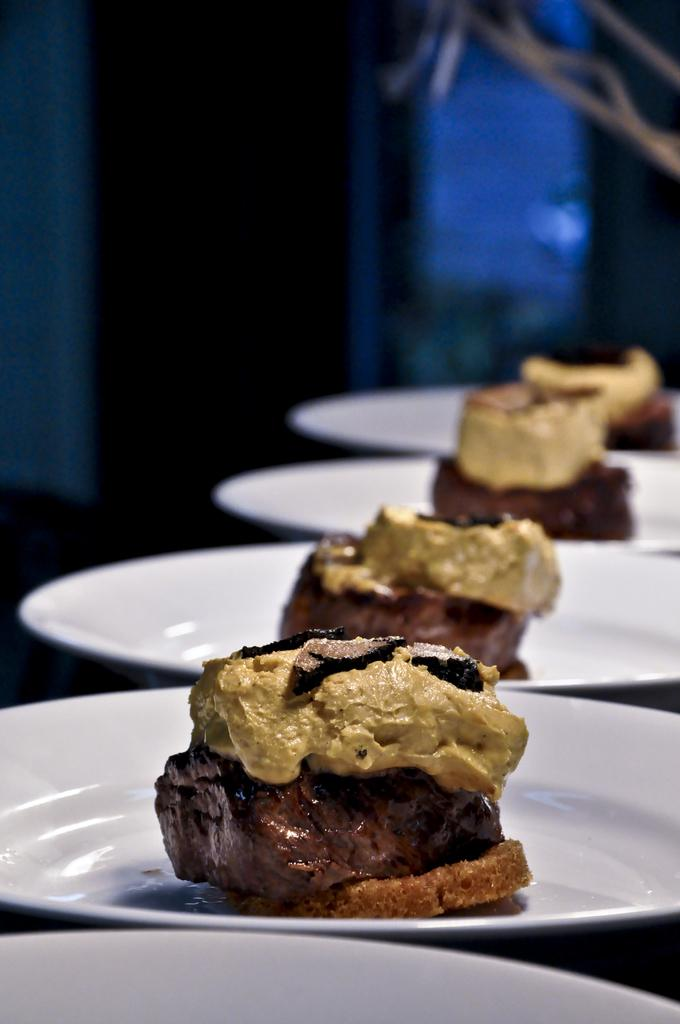What is located in the middle of the image? There are many white plates in the middle of the image. What is on the plates? The plates have food items on them. What color clothes can be seen in the background of the image? There are blue clothes in the background of the image. How many mice are hiding under the plates in the image? There are no mice present in the image; it only shows white plates with food items on them and blue clothes in the background. 